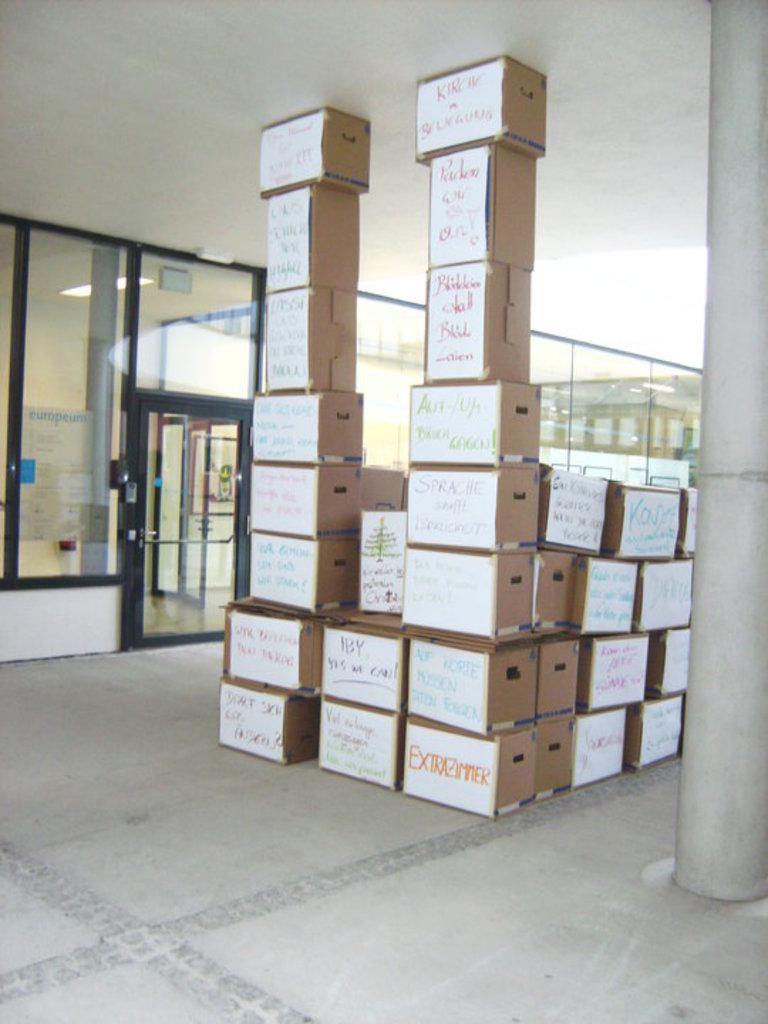Provide a one-sentence caption for the provided image. Tall stacks of cardboard boxes the bottom right one says Extrazimmer. 